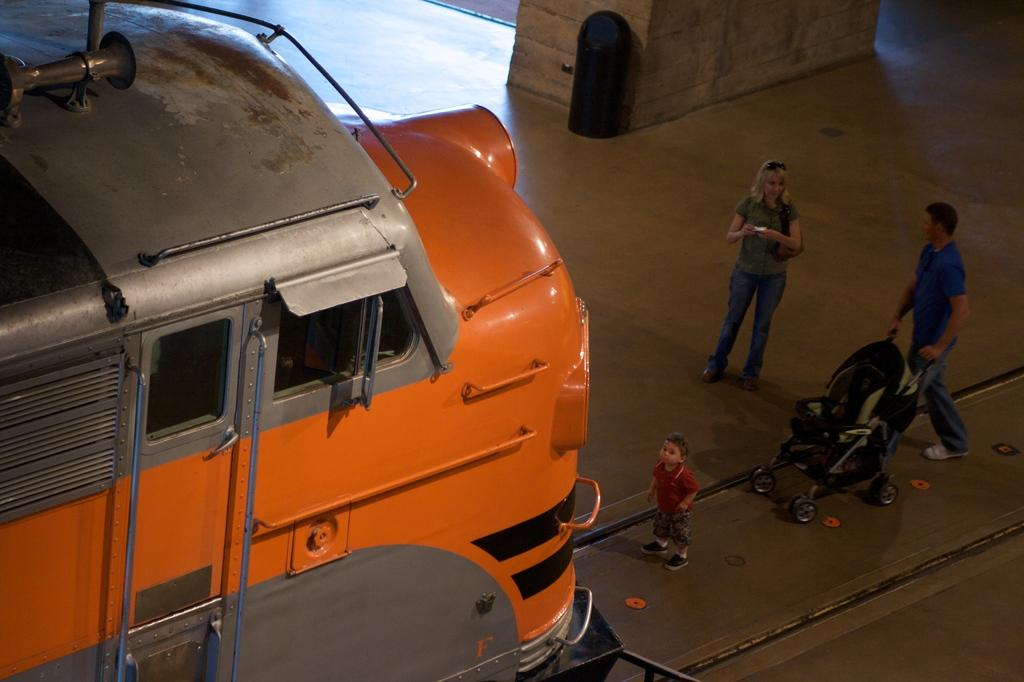What is the main object in the image? There is a vehicle in the image. Who are the people in the image? There is a woman, a man, and a kid in the image. What is the kid holding in the image? The kid is holding a baby stroller in the image. What other object can be seen in the image? There is a bin in the image. What type of hand can be seen holding a cattle in the image? There is no hand or cattle present in the image. What type of soda is being served in the image? There is no soda present in the image. 